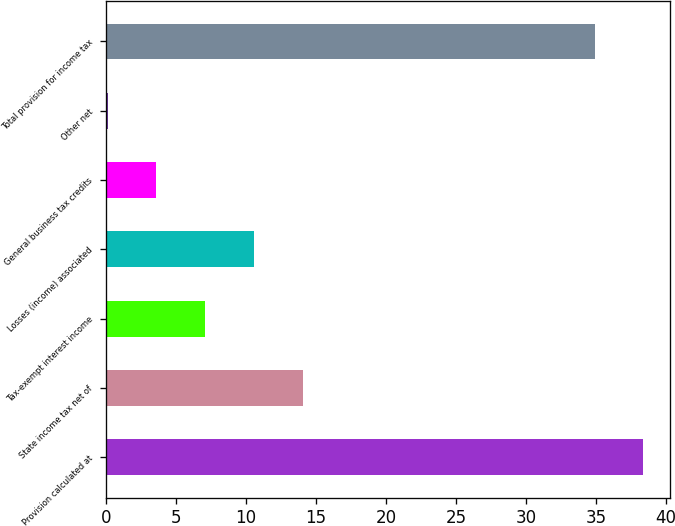<chart> <loc_0><loc_0><loc_500><loc_500><bar_chart><fcel>Provision calculated at<fcel>State income tax net of<fcel>Tax-exempt interest income<fcel>Losses (income) associated<fcel>General business tax credits<fcel>Other net<fcel>Total provision for income tax<nl><fcel>38.39<fcel>14.06<fcel>7.08<fcel>10.57<fcel>3.59<fcel>0.1<fcel>34.9<nl></chart> 